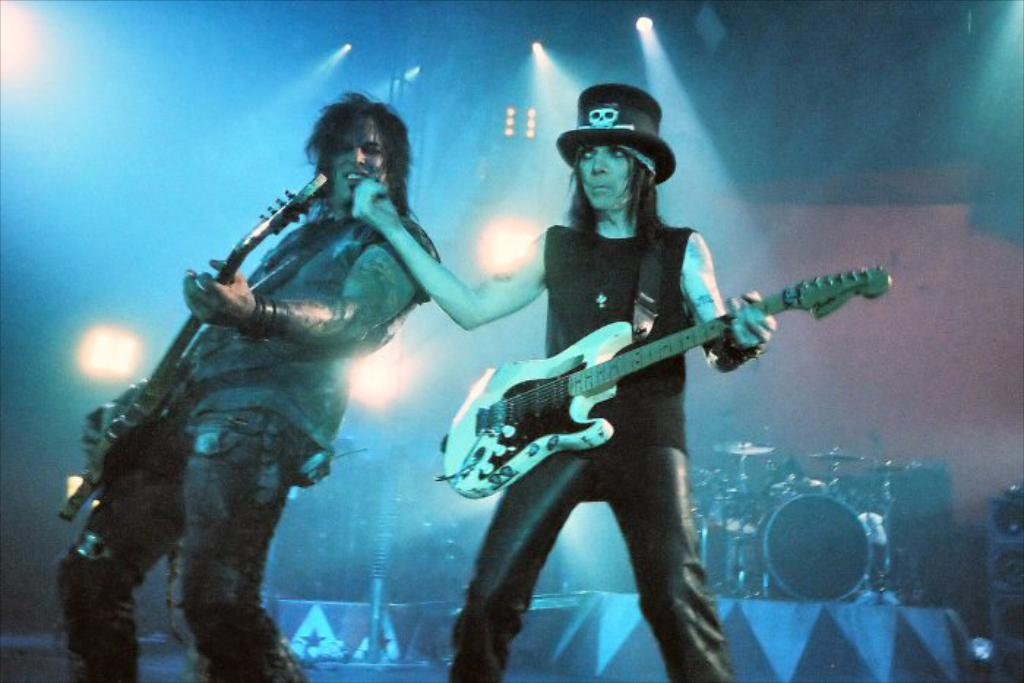Who are the people in the image? There is a woman and a man in the image. What are the man and woman doing in the image? The man and woman are holding a guitar. What else can be seen in the background of the image? There are a few other musical instruments and a wall visible in the background. Can you describe the lighting in the image? There is a light in the image. What type of pan is being used to cook food in the image? There is no pan or cooking activity present in the image. Can you describe the picture hanging on the wall in the image? There is no picture hanging on the wall in the image; only a wall is visible in the background. 